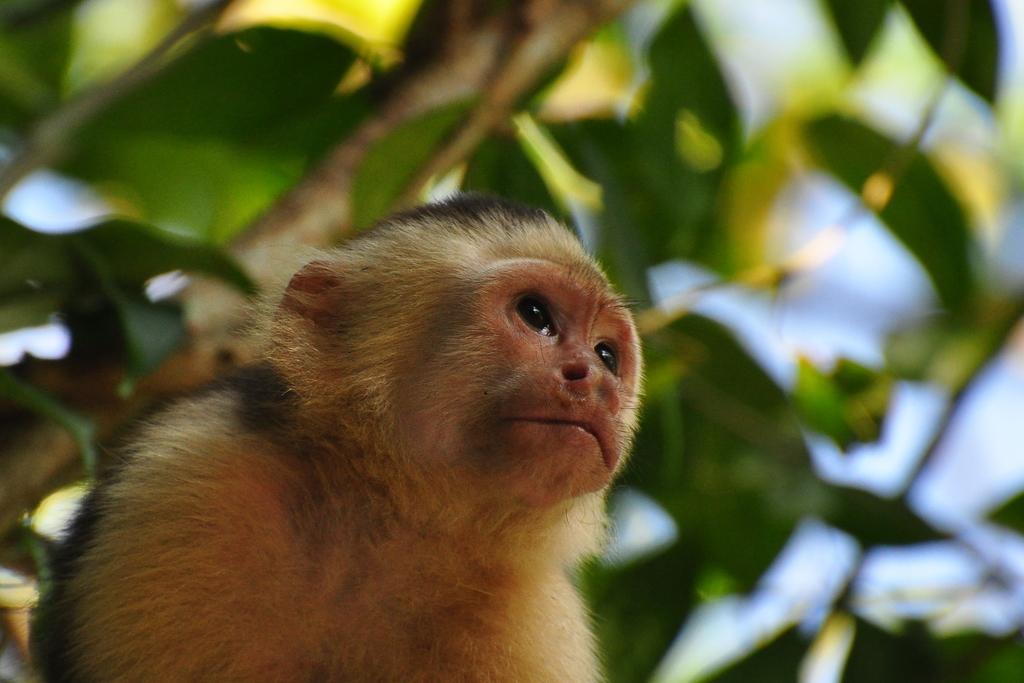What animal is present in the image? There is a monkey in the image. What is the monkey near or interacting with in the image? There is a tree in the image. Can you describe the background of the image? The background of the image is blurred. What historical event is depicted in the image involving the monkey and the tree? There is no historical event depicted in the image; it simply shows a monkey near a tree with a blurred background. 